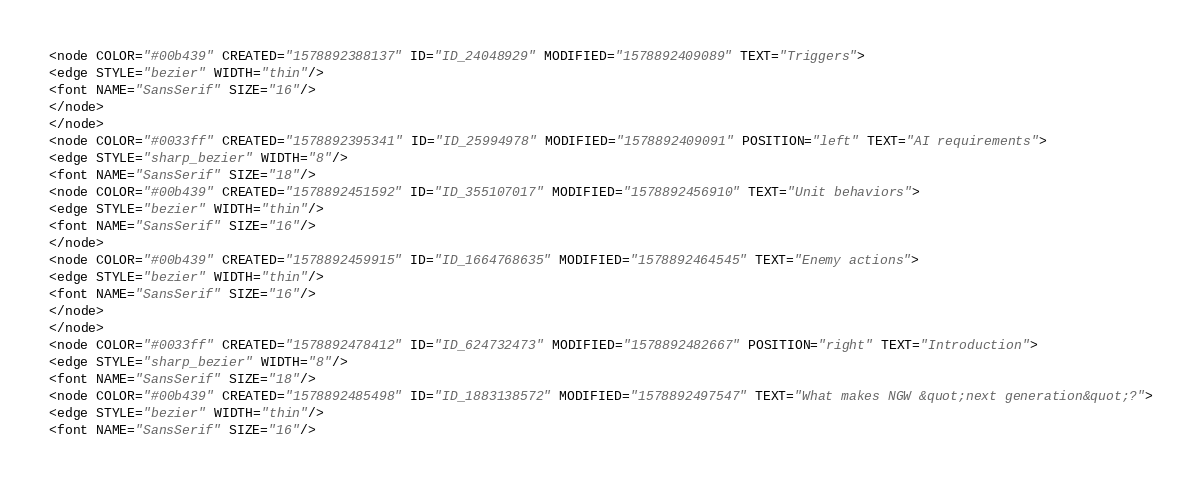<code> <loc_0><loc_0><loc_500><loc_500><_ObjectiveC_><node COLOR="#00b439" CREATED="1578892388137" ID="ID_24048929" MODIFIED="1578892409089" TEXT="Triggers">
<edge STYLE="bezier" WIDTH="thin"/>
<font NAME="SansSerif" SIZE="16"/>
</node>
</node>
<node COLOR="#0033ff" CREATED="1578892395341" ID="ID_25994978" MODIFIED="1578892409091" POSITION="left" TEXT="AI requirements">
<edge STYLE="sharp_bezier" WIDTH="8"/>
<font NAME="SansSerif" SIZE="18"/>
<node COLOR="#00b439" CREATED="1578892451592" ID="ID_355107017" MODIFIED="1578892456910" TEXT="Unit behaviors">
<edge STYLE="bezier" WIDTH="thin"/>
<font NAME="SansSerif" SIZE="16"/>
</node>
<node COLOR="#00b439" CREATED="1578892459915" ID="ID_1664768635" MODIFIED="1578892464545" TEXT="Enemy actions">
<edge STYLE="bezier" WIDTH="thin"/>
<font NAME="SansSerif" SIZE="16"/>
</node>
</node>
<node COLOR="#0033ff" CREATED="1578892478412" ID="ID_624732473" MODIFIED="1578892482667" POSITION="right" TEXT="Introduction">
<edge STYLE="sharp_bezier" WIDTH="8"/>
<font NAME="SansSerif" SIZE="18"/>
<node COLOR="#00b439" CREATED="1578892485498" ID="ID_1883138572" MODIFIED="1578892497547" TEXT="What makes NGW &quot;next generation&quot;?">
<edge STYLE="bezier" WIDTH="thin"/>
<font NAME="SansSerif" SIZE="16"/></code> 